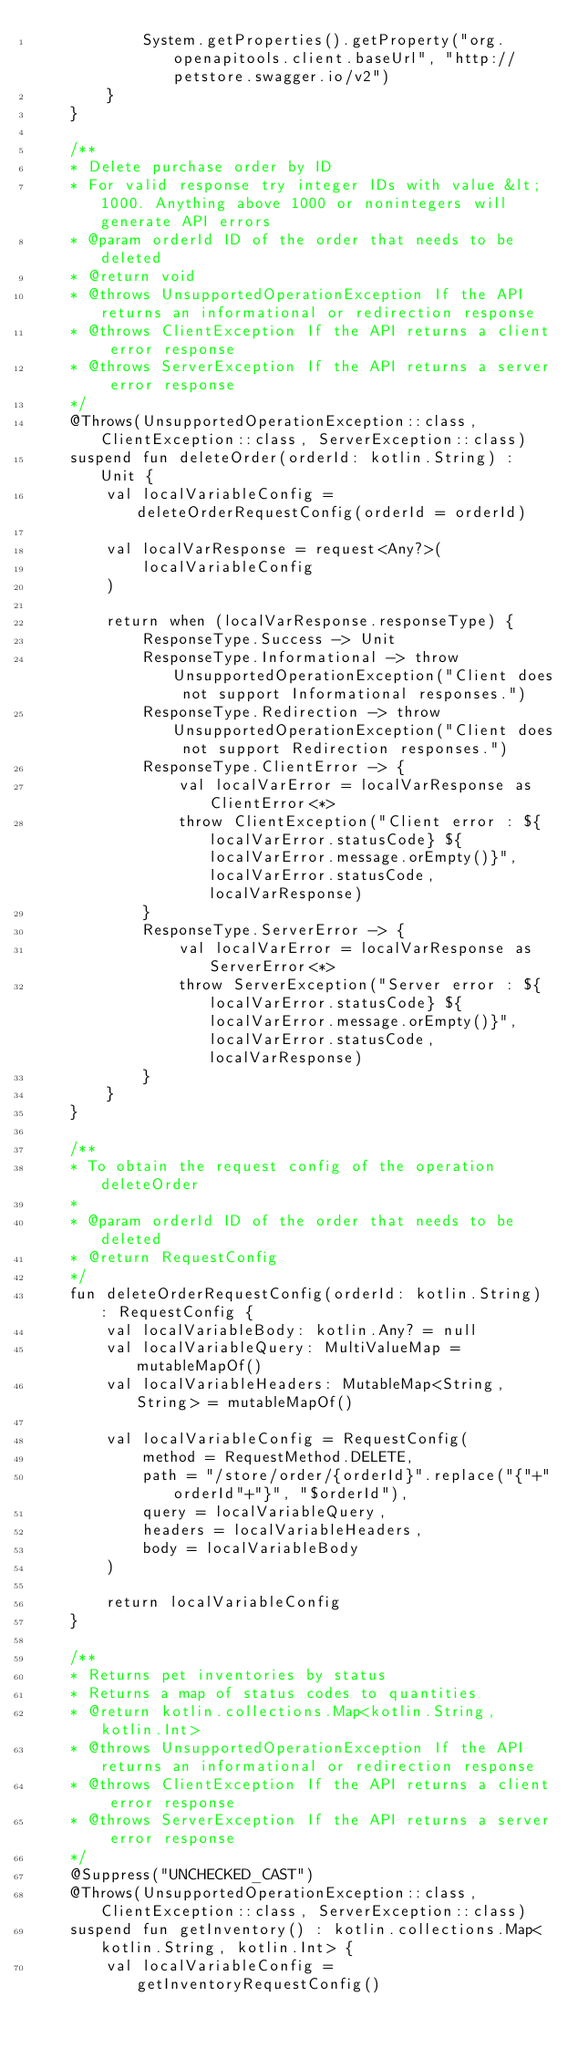Convert code to text. <code><loc_0><loc_0><loc_500><loc_500><_Kotlin_>            System.getProperties().getProperty("org.openapitools.client.baseUrl", "http://petstore.swagger.io/v2")
        }
    }

    /**
    * Delete purchase order by ID
    * For valid response try integer IDs with value &lt; 1000. Anything above 1000 or nonintegers will generate API errors
    * @param orderId ID of the order that needs to be deleted 
    * @return void
    * @throws UnsupportedOperationException If the API returns an informational or redirection response
    * @throws ClientException If the API returns a client error response
    * @throws ServerException If the API returns a server error response
    */
    @Throws(UnsupportedOperationException::class, ClientException::class, ServerException::class)
    suspend fun deleteOrder(orderId: kotlin.String) : Unit {
        val localVariableConfig = deleteOrderRequestConfig(orderId = orderId)

        val localVarResponse = request<Any?>(
            localVariableConfig
        )

        return when (localVarResponse.responseType) {
            ResponseType.Success -> Unit
            ResponseType.Informational -> throw UnsupportedOperationException("Client does not support Informational responses.")
            ResponseType.Redirection -> throw UnsupportedOperationException("Client does not support Redirection responses.")
            ResponseType.ClientError -> {
                val localVarError = localVarResponse as ClientError<*>
                throw ClientException("Client error : ${localVarError.statusCode} ${localVarError.message.orEmpty()}", localVarError.statusCode, localVarResponse)
            }
            ResponseType.ServerError -> {
                val localVarError = localVarResponse as ServerError<*>
                throw ServerException("Server error : ${localVarError.statusCode} ${localVarError.message.orEmpty()}", localVarError.statusCode, localVarResponse)
            }
        }
    }

    /**
    * To obtain the request config of the operation deleteOrder
    *
    * @param orderId ID of the order that needs to be deleted 
    * @return RequestConfig
    */
    fun deleteOrderRequestConfig(orderId: kotlin.String) : RequestConfig {
        val localVariableBody: kotlin.Any? = null
        val localVariableQuery: MultiValueMap = mutableMapOf()
        val localVariableHeaders: MutableMap<String, String> = mutableMapOf()
        
        val localVariableConfig = RequestConfig(
            method = RequestMethod.DELETE,
            path = "/store/order/{orderId}".replace("{"+"orderId"+"}", "$orderId"),
            query = localVariableQuery,
            headers = localVariableHeaders,
            body = localVariableBody
        )

        return localVariableConfig
    }

    /**
    * Returns pet inventories by status
    * Returns a map of status codes to quantities
    * @return kotlin.collections.Map<kotlin.String, kotlin.Int>
    * @throws UnsupportedOperationException If the API returns an informational or redirection response
    * @throws ClientException If the API returns a client error response
    * @throws ServerException If the API returns a server error response
    */
    @Suppress("UNCHECKED_CAST")
    @Throws(UnsupportedOperationException::class, ClientException::class, ServerException::class)
    suspend fun getInventory() : kotlin.collections.Map<kotlin.String, kotlin.Int> {
        val localVariableConfig = getInventoryRequestConfig()
</code> 